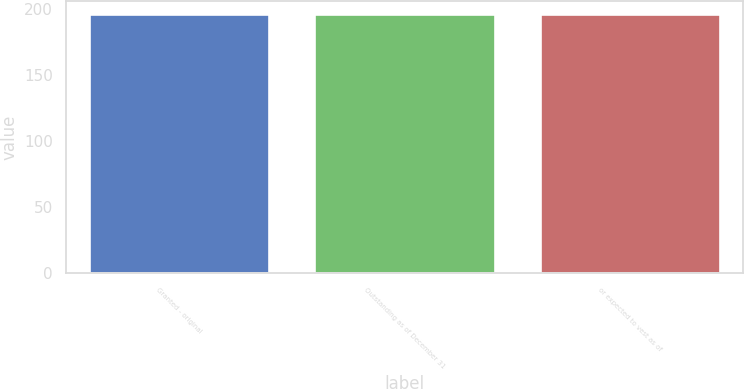<chart> <loc_0><loc_0><loc_500><loc_500><bar_chart><fcel>Granted - original<fcel>Outstanding as of December 31<fcel>or expected to vest as of<nl><fcel>195.98<fcel>196.08<fcel>196.18<nl></chart> 